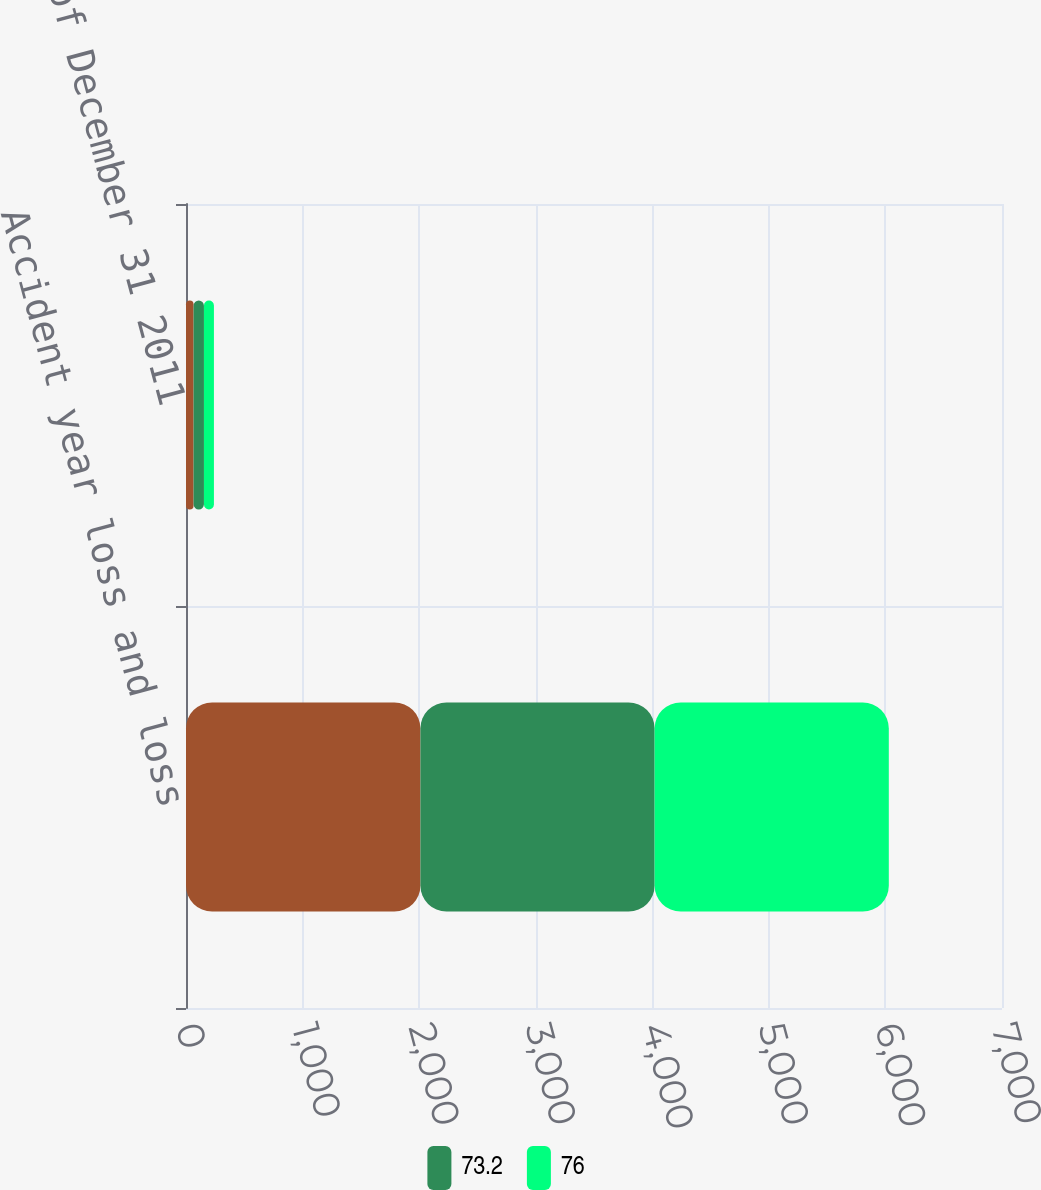<chart> <loc_0><loc_0><loc_500><loc_500><stacked_bar_chart><ecel><fcel>Accident year loss and loss<fcel>as of December 31 2011<nl><fcel>nan<fcel>2011<fcel>65<nl><fcel>73.2<fcel>2009<fcel>89<nl><fcel>76<fcel>2009<fcel>85.6<nl></chart> 